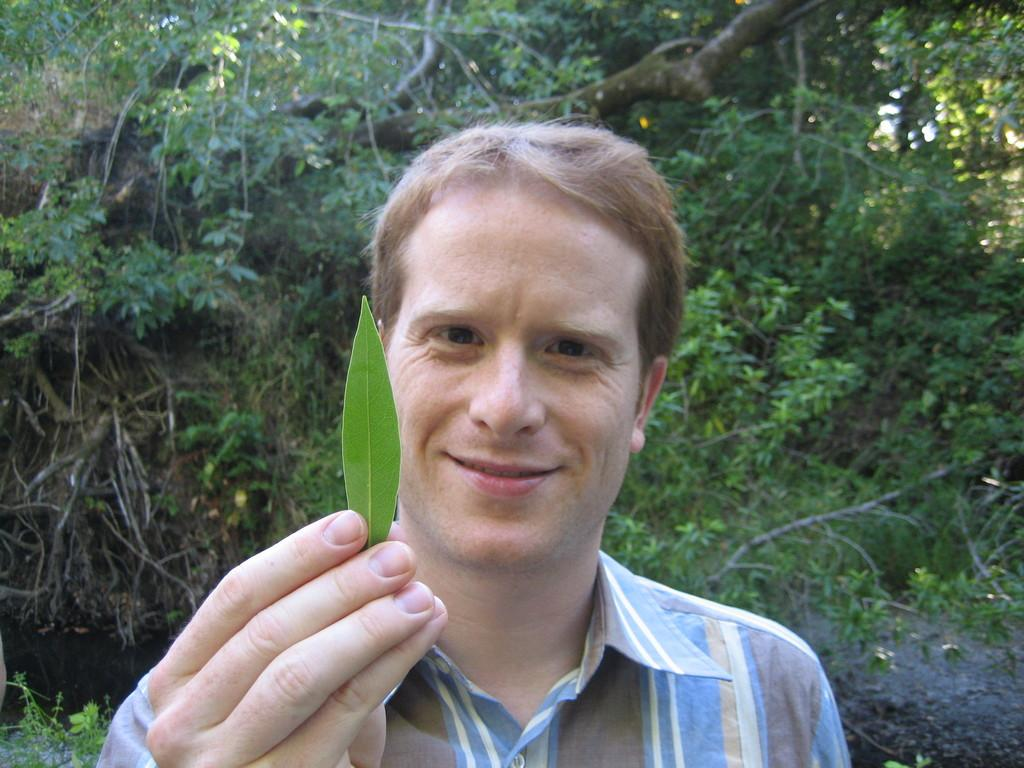What is the main subject of the image? There is a man in the image. What is the man holding in his hand? The man is holding a leaf in his hand. What can be seen in the background of the image? There are trees in the background of the image. What type of food is the man offering to the person sitting on the sofa in the image? There is no person sitting on a sofa in the image, nor is there any food being offered. 